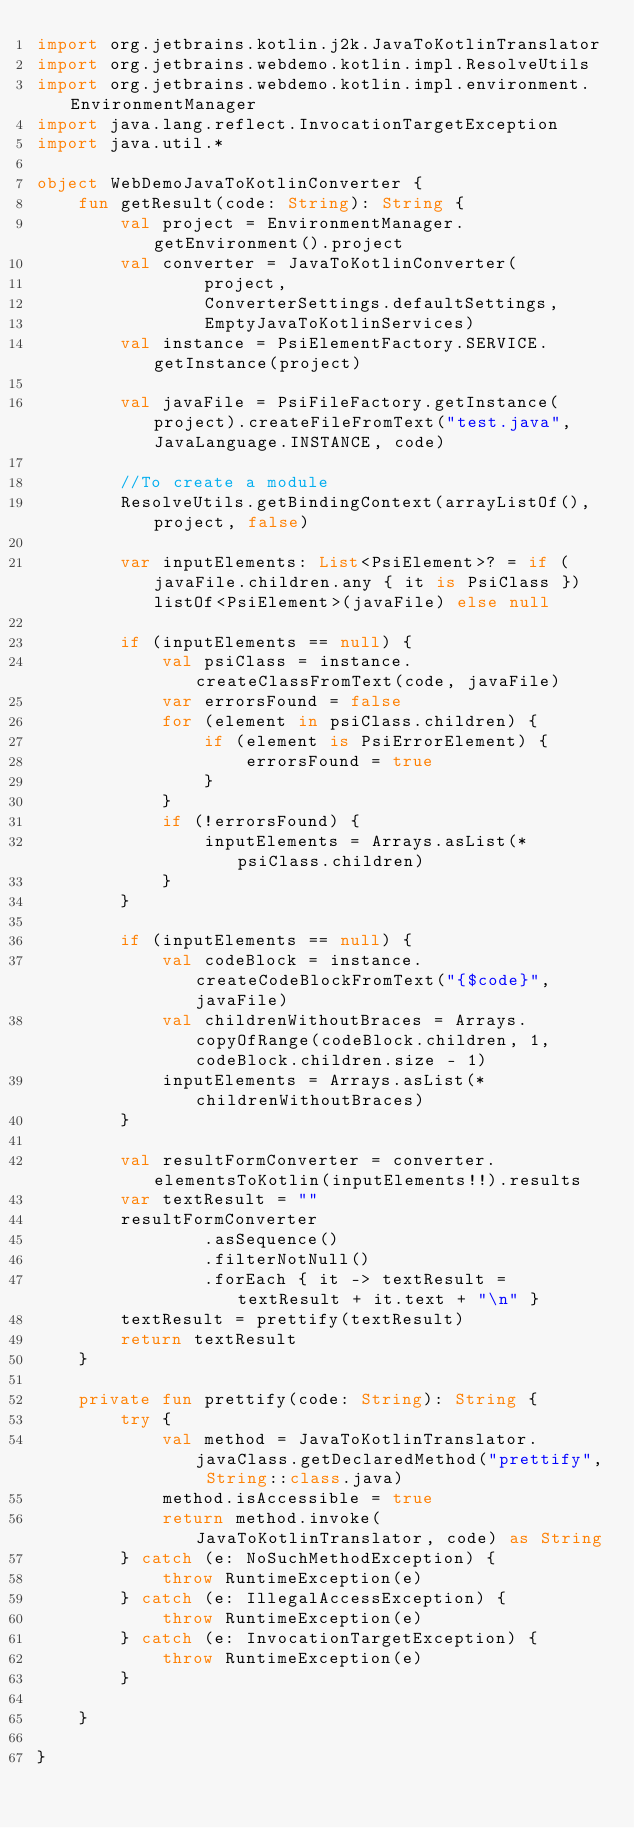<code> <loc_0><loc_0><loc_500><loc_500><_Kotlin_>import org.jetbrains.kotlin.j2k.JavaToKotlinTranslator
import org.jetbrains.webdemo.kotlin.impl.ResolveUtils
import org.jetbrains.webdemo.kotlin.impl.environment.EnvironmentManager
import java.lang.reflect.InvocationTargetException
import java.util.*

object WebDemoJavaToKotlinConverter {
    fun getResult(code: String): String {
        val project = EnvironmentManager.getEnvironment().project
        val converter = JavaToKotlinConverter(
                project,
                ConverterSettings.defaultSettings,
                EmptyJavaToKotlinServices)
        val instance = PsiElementFactory.SERVICE.getInstance(project)

        val javaFile = PsiFileFactory.getInstance(project).createFileFromText("test.java", JavaLanguage.INSTANCE, code)

        //To create a module
        ResolveUtils.getBindingContext(arrayListOf(), project, false)

        var inputElements: List<PsiElement>? = if (javaFile.children.any { it is PsiClass }) listOf<PsiElement>(javaFile) else null

        if (inputElements == null) {
            val psiClass = instance.createClassFromText(code, javaFile)
            var errorsFound = false
            for (element in psiClass.children) {
                if (element is PsiErrorElement) {
                    errorsFound = true
                }
            }
            if (!errorsFound) {
                inputElements = Arrays.asList(*psiClass.children)
            }
        }

        if (inputElements == null) {
            val codeBlock = instance.createCodeBlockFromText("{$code}", javaFile)
            val childrenWithoutBraces = Arrays.copyOfRange(codeBlock.children, 1, codeBlock.children.size - 1)
            inputElements = Arrays.asList(*childrenWithoutBraces)
        }

        val resultFormConverter = converter.elementsToKotlin(inputElements!!).results
        var textResult = ""
        resultFormConverter
                .asSequence()
                .filterNotNull()
                .forEach { it -> textResult = textResult + it.text + "\n" }
        textResult = prettify(textResult)
        return textResult
    }

    private fun prettify(code: String): String {
        try {
            val method = JavaToKotlinTranslator.javaClass.getDeclaredMethod("prettify", String::class.java)
            method.isAccessible = true
            return method.invoke(JavaToKotlinTranslator, code) as String
        } catch (e: NoSuchMethodException) {
            throw RuntimeException(e)
        } catch (e: IllegalAccessException) {
            throw RuntimeException(e)
        } catch (e: InvocationTargetException) {
            throw RuntimeException(e)
        }

    }

}
</code> 